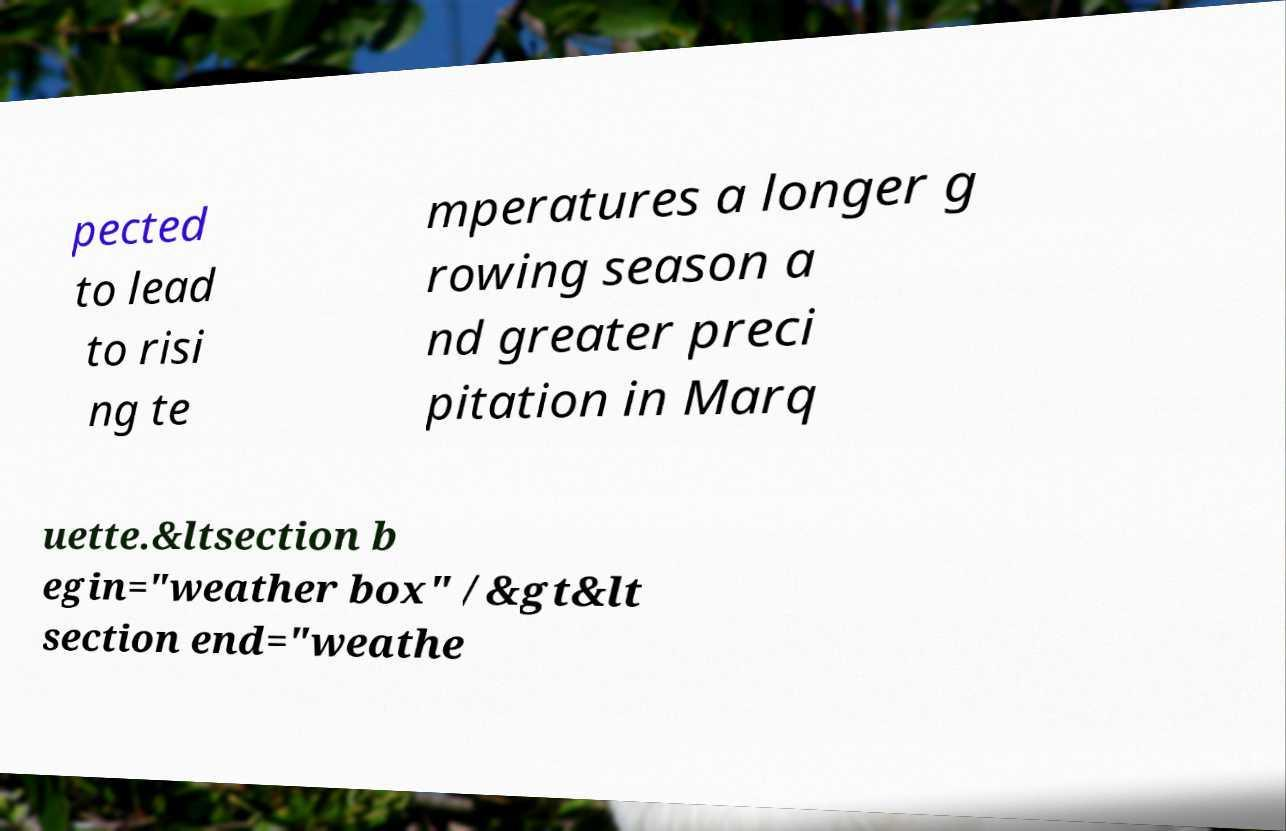Could you assist in decoding the text presented in this image and type it out clearly? pected to lead to risi ng te mperatures a longer g rowing season a nd greater preci pitation in Marq uette.&ltsection b egin="weather box" /&gt&lt section end="weathe 